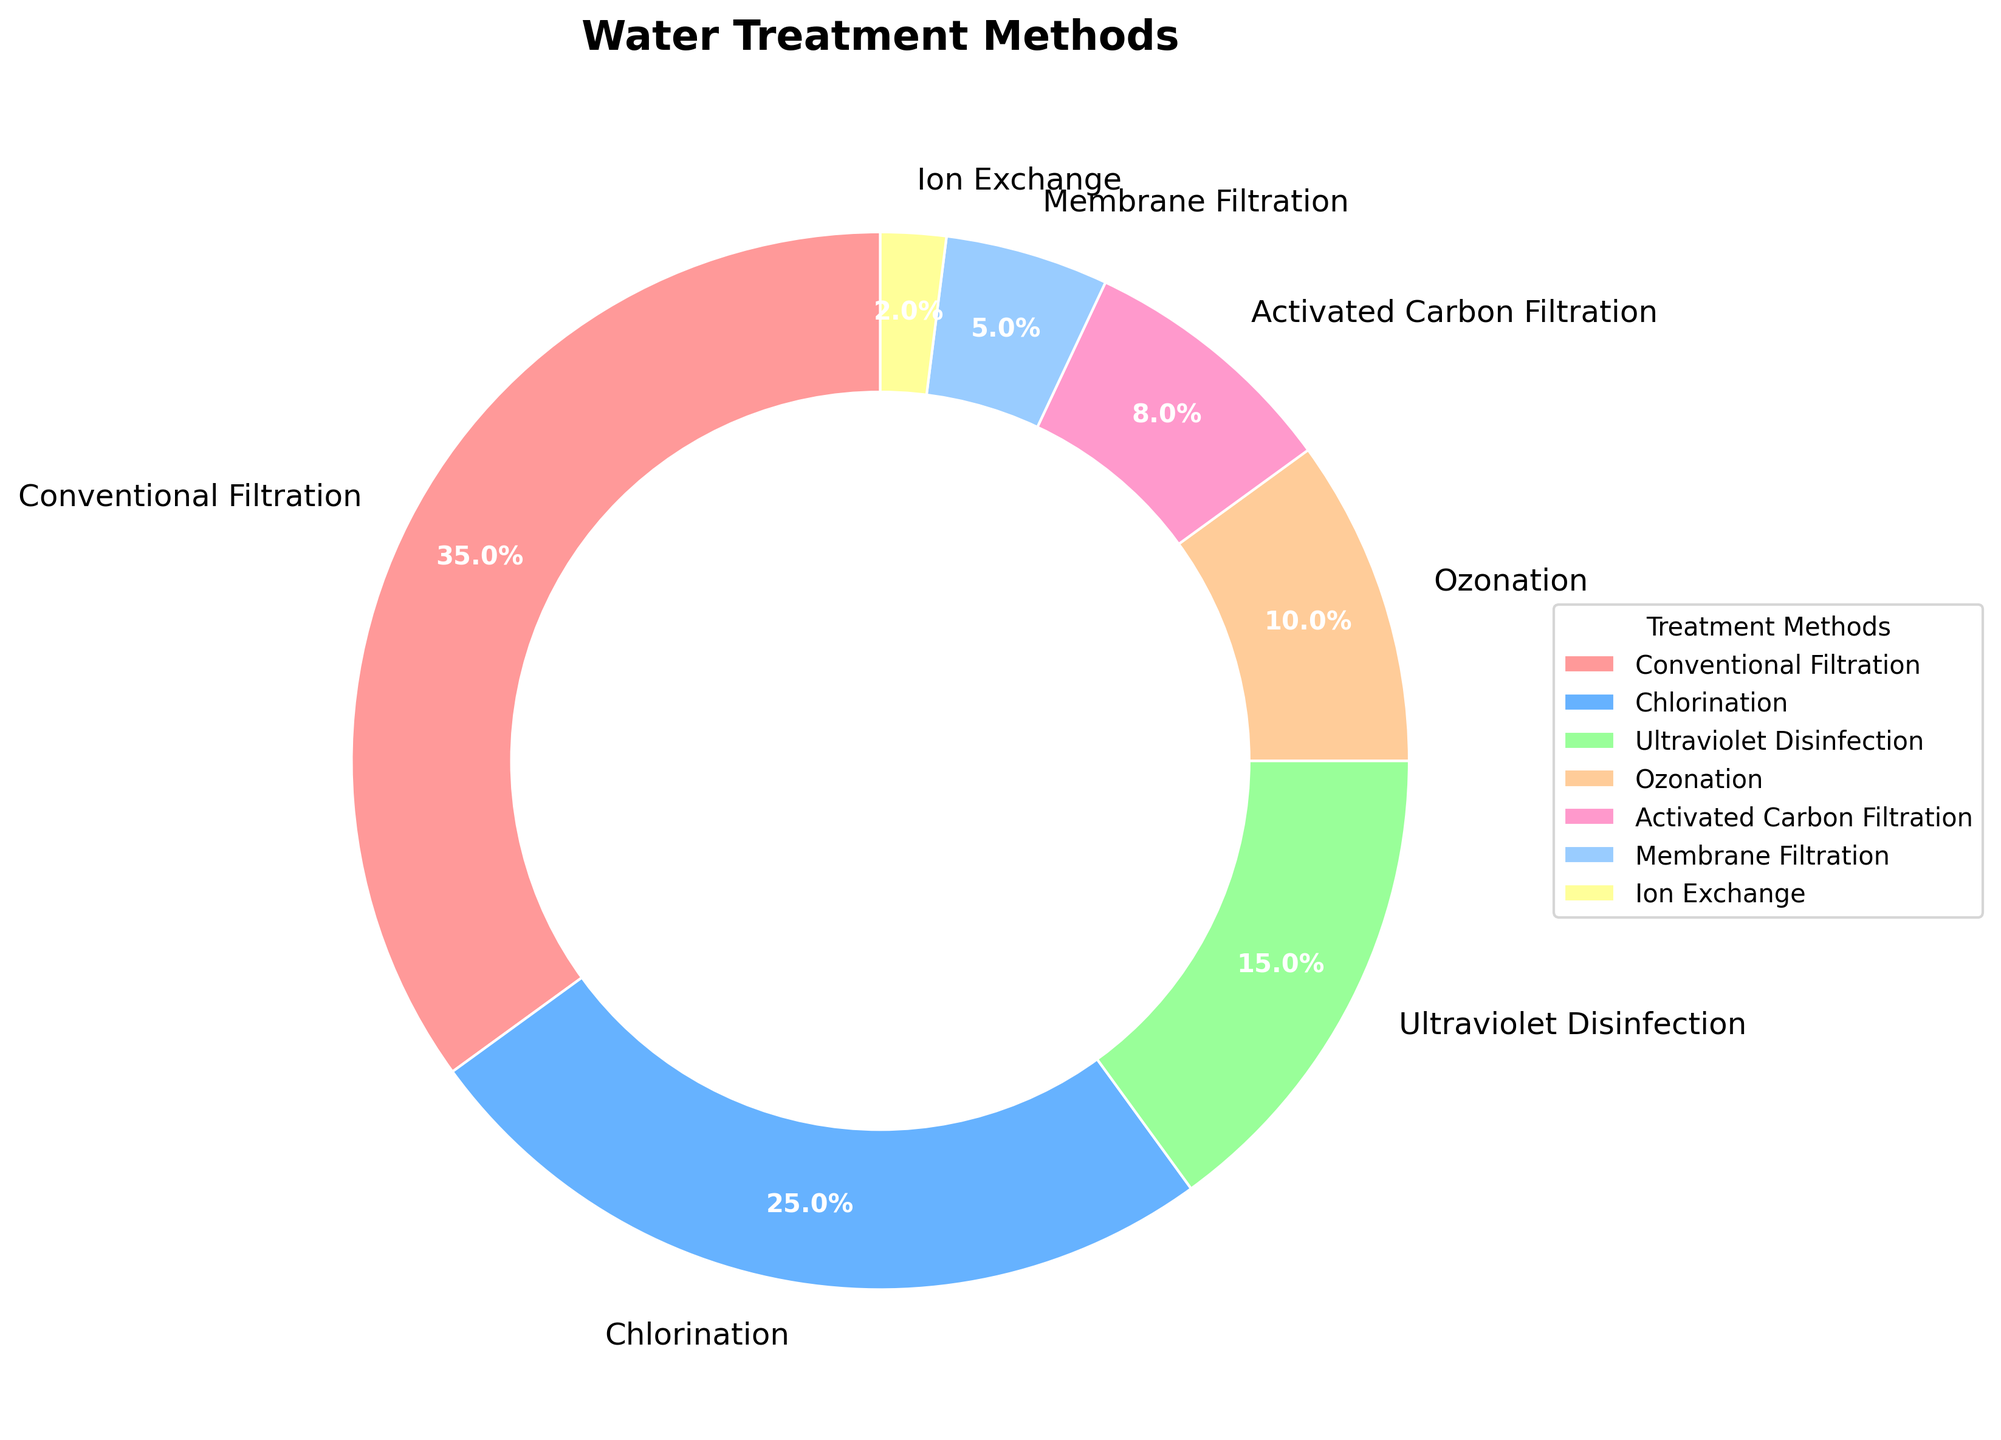Which water treatment method has the highest percentage? The pie chart visually indicates that the wedge for "Conventional Filtration" is the largest compared to all other methods. Thus, "Conventional Filtration" is the water treatment method with the highest percentage.
Answer: Conventional Filtration What is the total percentage of methods that use filtration techniques? Sum the percentages of all filtration methods in the pie chart: "Conventional Filtration" (35%), "Activated Carbon Filtration" (8%), and "Membrane Filtration" (5%). So, the total is 35% + 8% + 5% = 48%.
Answer: 48% How much more prevalent is Chlorination compared to Ion Exchange? Refer to the two wedges for "Chlorination" and "Ion Exchange" from the pie chart. "Chlorination" has 25% and "Ion Exchange" has 2%. The difference between them is 25% - 2% = 23%.
Answer: 23% Which water treatment methods combined make up less than or equal to 20% of the total? Look for methods with individual percentages adding up to less than or equal to 20%. "Ion Exchange" (2%) and "Membrane Filtration" (5%) sum up to 7%, and "Activated Carbon Filtration" (8%), added together, totals 15%. Adding "Ozonation" (10%) results in 25% exceeding the limit. So the suitable combinations are "Ion Exchange" and "Membrane Filtration", or "Ion Exchange", "Membrane Filtration", and "Activated Carbon Filtration".
Answer: Ion Exchange, Membrane Filtration, Activated Carbon Filtration What is the average percentage of non-filtration methods? First, identify non-filtration methods: "Chlorination" (25%), "Ultraviolet Disinfection" (15%), "Ozonation" (10%), and "Ion Exchange" (2%). Calculate their sum: 25% + 15% + 10% + 2% = 52%. Then find the average by dividing by the number of methods: 52% / 4 = 13%.
Answer: 13% What is the combined percentage of methods that use chemical processes? The methods involving chemical processes are "Chlorination" (25%) and "Ozonation" (10%). Their combined percentage is 25% + 10% = 35%.
Answer: 35% Which method is the least prevalent? The smallest wedge in the pie chart corresponds to "Ion Exchange" with a percentage of 2%.
Answer: Ion Exchange 